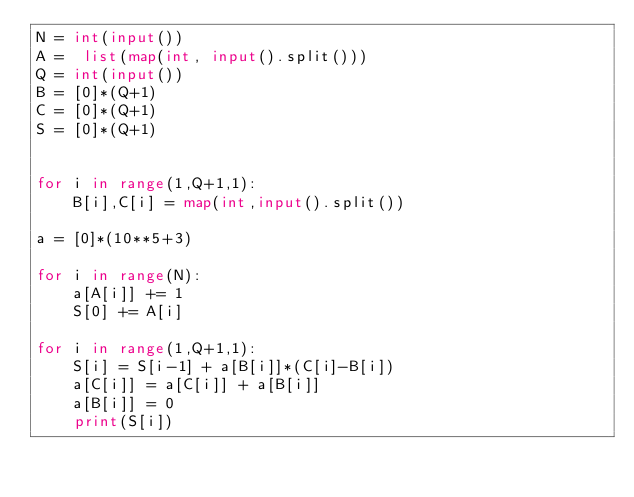<code> <loc_0><loc_0><loc_500><loc_500><_Python_>N = int(input())
A =  list(map(int, input().split()))
Q = int(input())
B = [0]*(Q+1)
C = [0]*(Q+1)
S = [0]*(Q+1)


for i in range(1,Q+1,1):
    B[i],C[i] = map(int,input().split())

a = [0]*(10**5+3)

for i in range(N):
    a[A[i]] += 1
    S[0] += A[i]

for i in range(1,Q+1,1):
    S[i] = S[i-1] + a[B[i]]*(C[i]-B[i])
    a[C[i]] = a[C[i]] + a[B[i]]
    a[B[i]] = 0
    print(S[i])</code> 